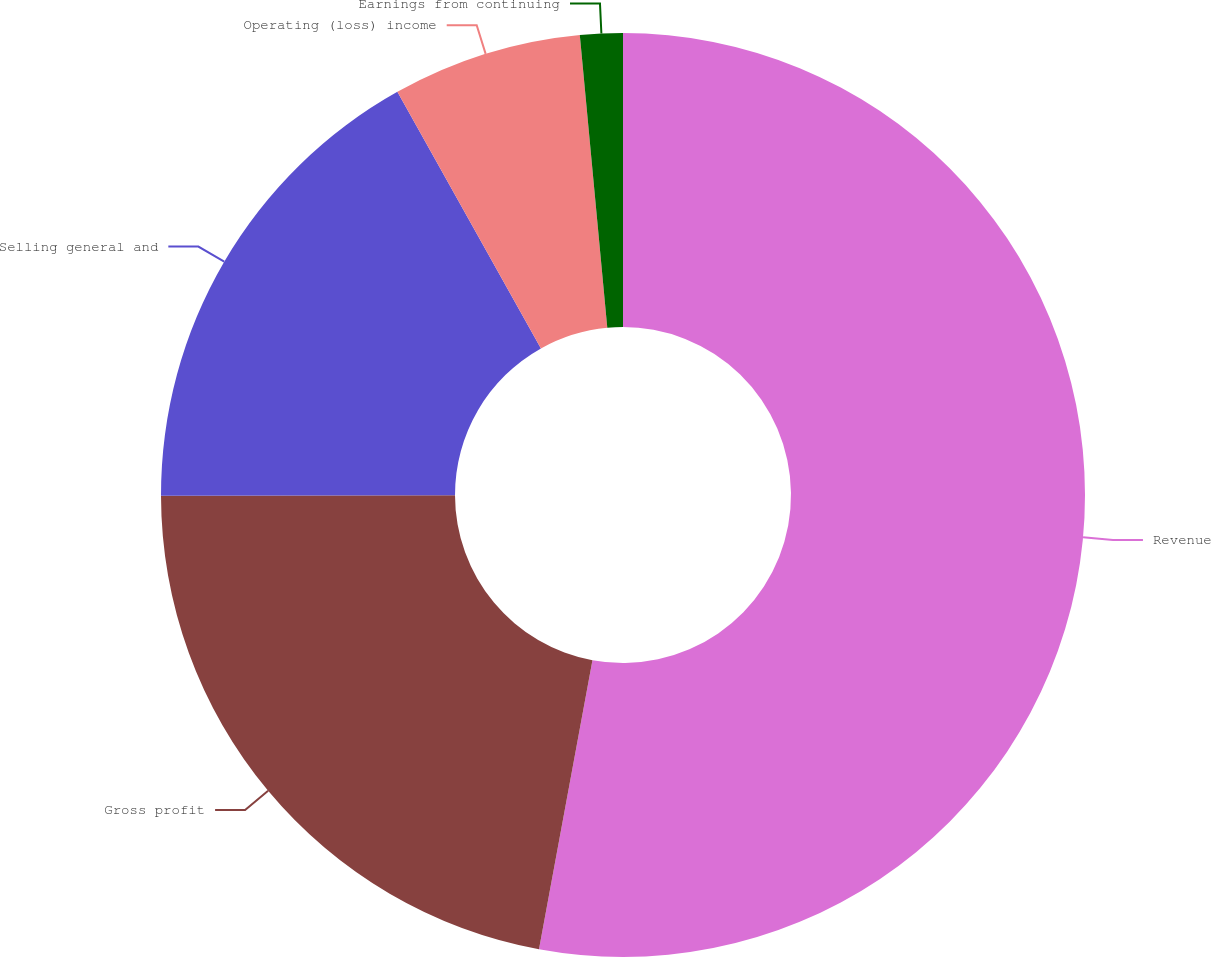<chart> <loc_0><loc_0><loc_500><loc_500><pie_chart><fcel>Revenue<fcel>Gross profit<fcel>Selling general and<fcel>Operating (loss) income<fcel>Earnings from continuing<nl><fcel>52.91%<fcel>22.06%<fcel>16.91%<fcel>6.63%<fcel>1.49%<nl></chart> 